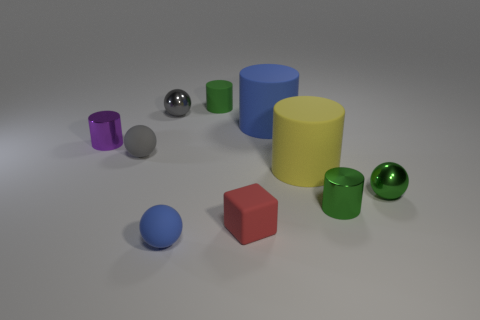Is the red object the same shape as the large yellow rubber thing?
Keep it short and to the point. No. There is a rubber thing that is in front of the tiny gray rubber sphere and behind the block; how big is it?
Offer a very short reply. Large. What material is the tiny blue object that is the same shape as the small gray matte object?
Your answer should be very brief. Rubber. What material is the tiny cylinder left of the tiny matte thing that is in front of the small red rubber cube?
Provide a short and direct response. Metal. There is a tiny blue object; is its shape the same as the green rubber object behind the purple cylinder?
Offer a terse response. No. What number of rubber things are blue things or large blue things?
Your answer should be compact. 2. There is a small cylinder that is on the left side of the tiny green cylinder that is behind the big object that is behind the yellow cylinder; what is its color?
Make the answer very short. Purple. What number of other things are the same material as the small purple cylinder?
Make the answer very short. 3. There is a blue matte thing right of the green rubber cylinder; is its shape the same as the large yellow rubber thing?
Keep it short and to the point. Yes. What number of small things are matte balls or cyan matte cubes?
Give a very brief answer. 2. 